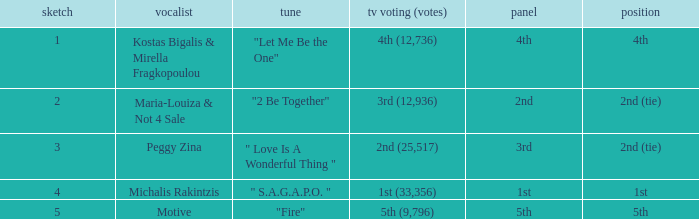Would you be able to parse every entry in this table? {'header': ['sketch', 'vocalist', 'tune', 'tv voting (votes)', 'panel', 'position'], 'rows': [['1', 'Kostas Bigalis & Mirella Fragkopoulou', '"Let Me Be the One"', '4th (12,736)', '4th', '4th'], ['2', 'Maria-Louiza & Not 4 Sale', '"2 Be Together"', '3rd (12,936)', '2nd', '2nd (tie)'], ['3', 'Peggy Zina', '" Love Is A Wonderful Thing "', '2nd (25,517)', '3rd', '2nd (tie)'], ['4', 'Michalis Rakintzis', '" S.A.G.A.P.O. "', '1st (33,356)', '1st', '1st'], ['5', 'Motive', '"Fire"', '5th (9,796)', '5th', '5th']]} What is the greatest draw that has 4th for place? 1.0. 